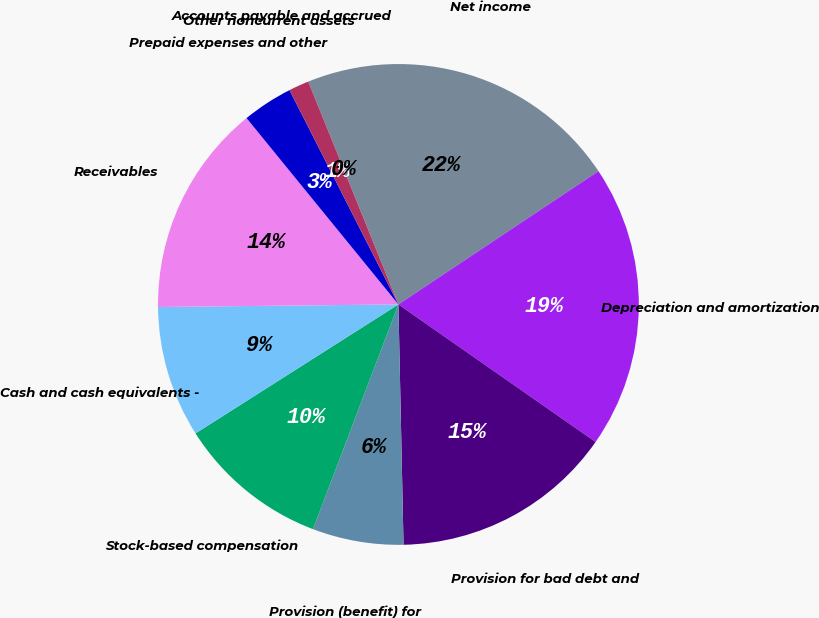<chart> <loc_0><loc_0><loc_500><loc_500><pie_chart><fcel>Net income<fcel>Depreciation and amortization<fcel>Provision for bad debt and<fcel>Provision (benefit) for<fcel>Stock-based compensation<fcel>Cash and cash equivalents -<fcel>Receivables<fcel>Prepaid expenses and other<fcel>Other noncurrent assets<fcel>Accounts payable and accrued<nl><fcel>21.76%<fcel>19.04%<fcel>14.96%<fcel>6.12%<fcel>10.2%<fcel>8.84%<fcel>14.28%<fcel>3.4%<fcel>1.36%<fcel>0.0%<nl></chart> 